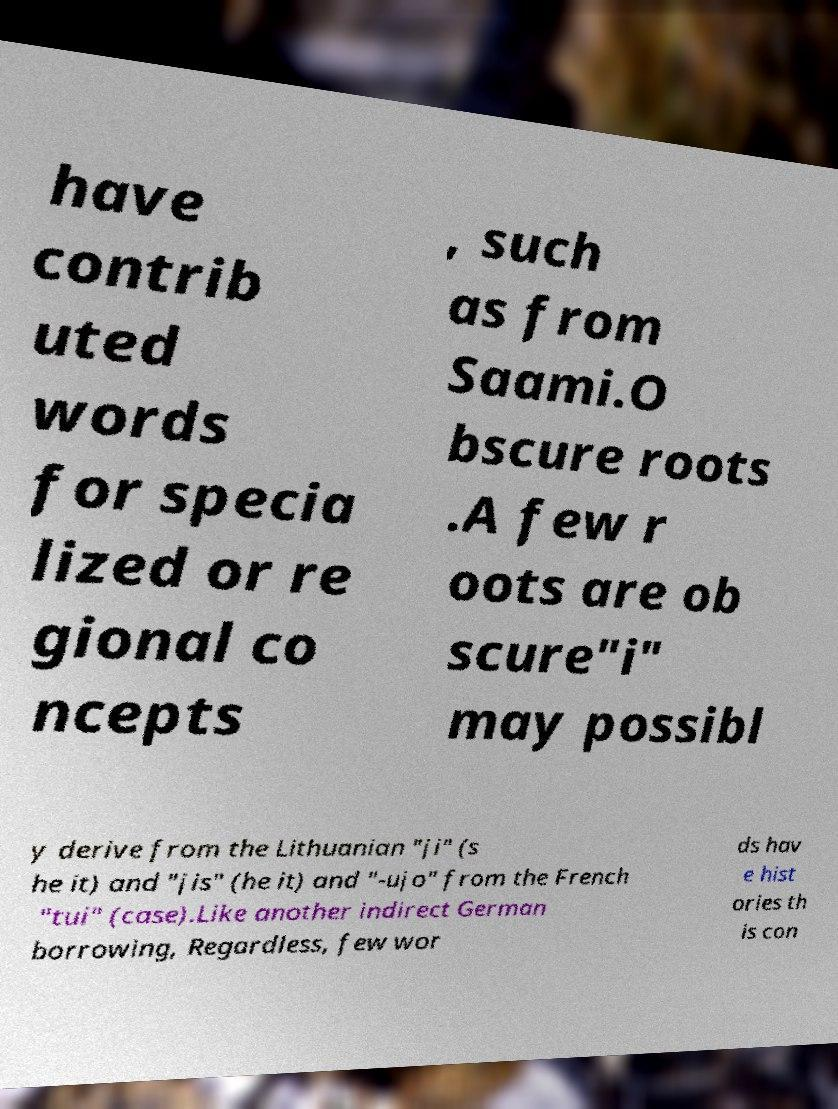Can you read and provide the text displayed in the image?This photo seems to have some interesting text. Can you extract and type it out for me? have contrib uted words for specia lized or re gional co ncepts , such as from Saami.O bscure roots .A few r oots are ob scure"i" may possibl y derive from the Lithuanian "ji" (s he it) and "jis" (he it) and "-ujo" from the French "tui" (case).Like another indirect German borrowing, Regardless, few wor ds hav e hist ories th is con 